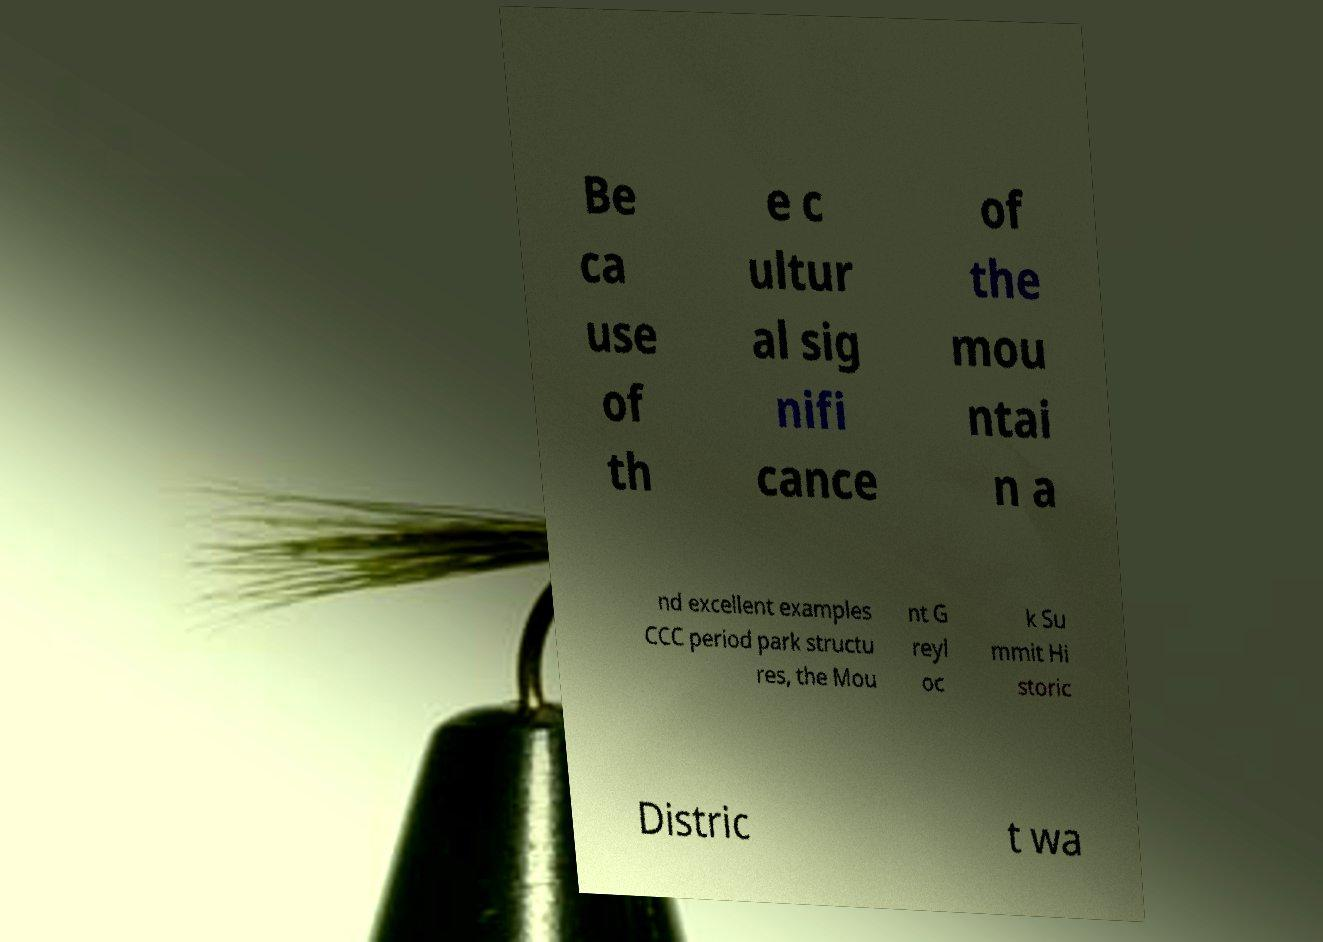Can you accurately transcribe the text from the provided image for me? Be ca use of th e c ultur al sig nifi cance of the mou ntai n a nd excellent examples CCC period park structu res, the Mou nt G reyl oc k Su mmit Hi storic Distric t wa 